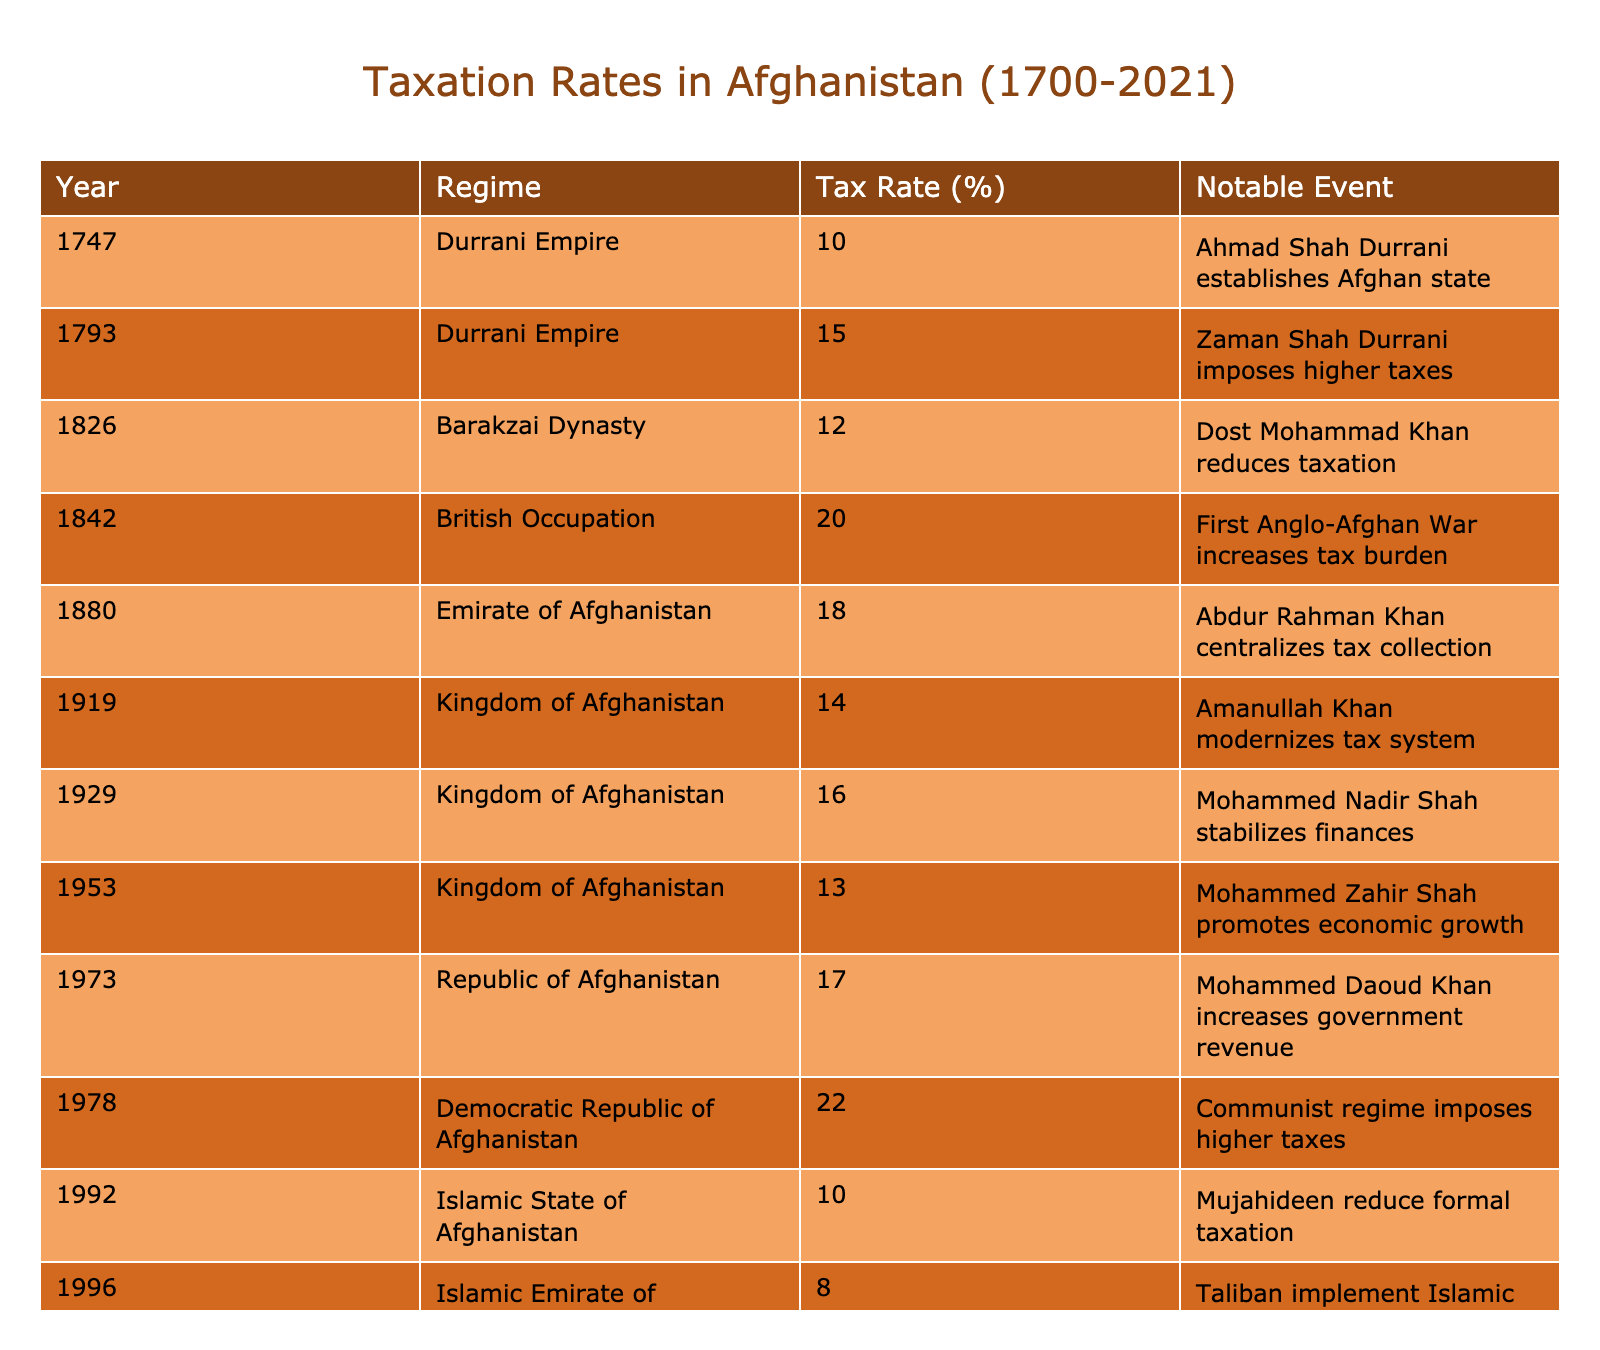What was the highest tax rate in Afghanistan during the given period? The highest tax rate in the table is 22%, which occurred in 1978 under the Democratic Republic of Afghanistan.
Answer: 22% Which regime had the lowest tax rate, and what was that rate? The lowest tax rate listed in the table is 8%, which was implemented by the Taliban in 1996.
Answer: 8% What was the average tax rate from 1700 to 2021? To find the average, sum all the tax rates: (10 + 15 + 12 + 20 + 18 + 14 + 16 + 13 + 17 + 22 + 10 + 8 + 12 + 15 + 9) =  257. Then divide by the number of years represented: 257/15 = 17.13 (rounded to two decimal places).
Answer: 17.13 Did the tax rate increase or decrease during the Durrani Empire from 1747 to 1793? In 1747, the tax rate was 10%, and by 1793 it had gone up to 15%. Therefore, the rate increased over that period.
Answer: Increase Compare the tax rates between the Islamic Emirate of Afghanistan in 1996 and 2021. In 1996, the tax rate was 8%, while in 2021, it was 9%. This shows that the tax rate increased by 1%.
Answer: Increased by 1% Which regime enacted the most significant increase in tax rate from a previous regime? The Democratic Republic of Afghanistan in 1978 imposed the highest increase, raising it to 22%, a rise from 17% under the Republic of Afghanistan in 1973, which is a 5% increase.
Answer: Democratic Republic of Afghanistan What notable event coincided with the tax rate of 14% in 1919? The notable event in 1919 when the tax rate was 14% was Amanullah Khan modernizing the tax system.
Answer: Amanullah Khan modernizing the tax system Did any regime reduce the tax rate more than once? Yes, the Mujahideen in 1992 reduced formal taxation to 10%, down from 22% in 1978, and the Taliban in 1996 also implemented a low tax rate of 8%.
Answer: Yes What pattern can you observe in the tax rates of the Kingdom of Afghanistan? The tax rates in the Kingdom fluctuated: starting at 14% in 1919, increased to 16% by 1929, and decreased to 13% in 1953, before rising again to 17% in 1973. This indicates a pattern of both increases and decreases.
Answer: Fluctuated How much did the tax rate increase from the Durrani Empire's peak in 1793 to the British Occupation in 1842? The tax rate increased from 15% in 1793 to 20% in 1842, a difference of 5%.
Answer: Increased by 5% Was there a time when the tax rate was below 10%? Yes, there were two instances: 1996 with 8% and 2021 with 9%.
Answer: Yes, two instances 